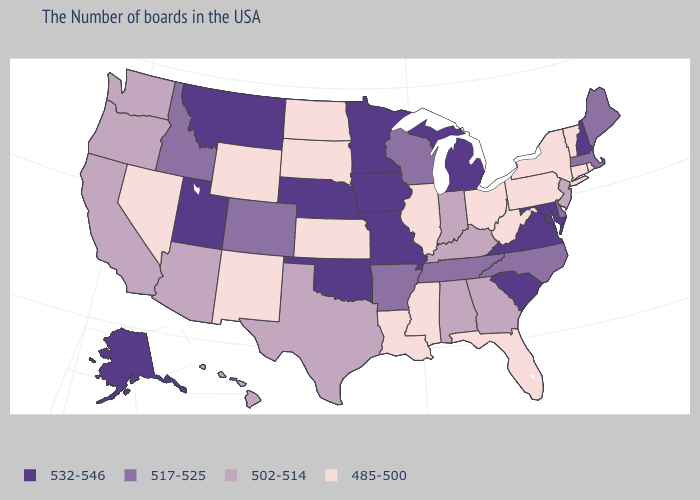Does South Dakota have the lowest value in the USA?
Concise answer only. Yes. What is the highest value in the South ?
Be succinct. 532-546. What is the value of New Jersey?
Answer briefly. 502-514. What is the value of South Carolina?
Give a very brief answer. 532-546. What is the value of Utah?
Write a very short answer. 532-546. What is the lowest value in the West?
Quick response, please. 485-500. Name the states that have a value in the range 502-514?
Keep it brief. New Jersey, Georgia, Kentucky, Indiana, Alabama, Texas, Arizona, California, Washington, Oregon, Hawaii. Name the states that have a value in the range 485-500?
Write a very short answer. Rhode Island, Vermont, Connecticut, New York, Pennsylvania, West Virginia, Ohio, Florida, Illinois, Mississippi, Louisiana, Kansas, South Dakota, North Dakota, Wyoming, New Mexico, Nevada. Name the states that have a value in the range 485-500?
Short answer required. Rhode Island, Vermont, Connecticut, New York, Pennsylvania, West Virginia, Ohio, Florida, Illinois, Mississippi, Louisiana, Kansas, South Dakota, North Dakota, Wyoming, New Mexico, Nevada. Is the legend a continuous bar?
Write a very short answer. No. Name the states that have a value in the range 532-546?
Give a very brief answer. New Hampshire, Maryland, Virginia, South Carolina, Michigan, Missouri, Minnesota, Iowa, Nebraska, Oklahoma, Utah, Montana, Alaska. Name the states that have a value in the range 532-546?
Short answer required. New Hampshire, Maryland, Virginia, South Carolina, Michigan, Missouri, Minnesota, Iowa, Nebraska, Oklahoma, Utah, Montana, Alaska. Which states have the highest value in the USA?
Keep it brief. New Hampshire, Maryland, Virginia, South Carolina, Michigan, Missouri, Minnesota, Iowa, Nebraska, Oklahoma, Utah, Montana, Alaska. Does the map have missing data?
Quick response, please. No. 